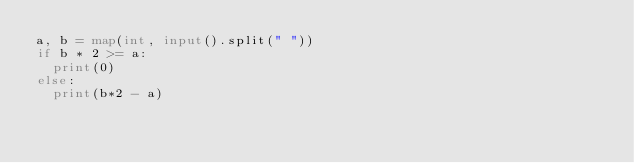Convert code to text. <code><loc_0><loc_0><loc_500><loc_500><_Python_>a, b = map(int, input().split(" "))
if b * 2 >= a:
  print(0)
else:
  print(b*2 - a)</code> 